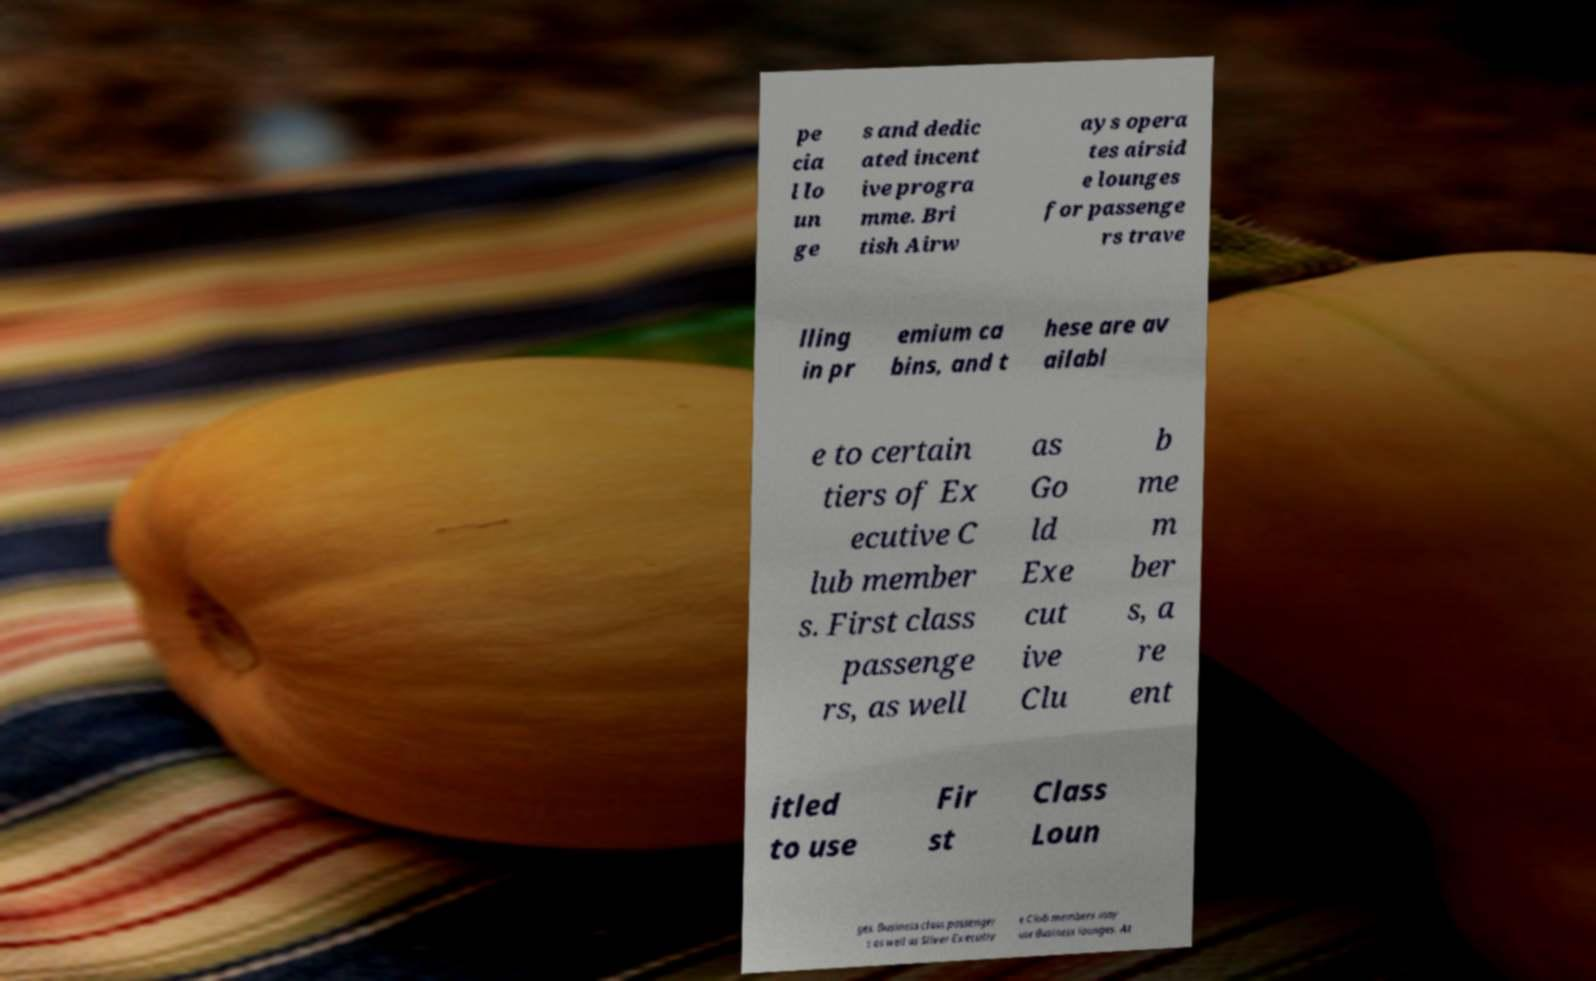Please read and relay the text visible in this image. What does it say? pe cia l lo un ge s and dedic ated incent ive progra mme. Bri tish Airw ays opera tes airsid e lounges for passenge rs trave lling in pr emium ca bins, and t hese are av ailabl e to certain tiers of Ex ecutive C lub member s. First class passenge rs, as well as Go ld Exe cut ive Clu b me m ber s, a re ent itled to use Fir st Class Loun ges. Business class passenger s as well as Silver Executiv e Club members may use Business lounges. At 